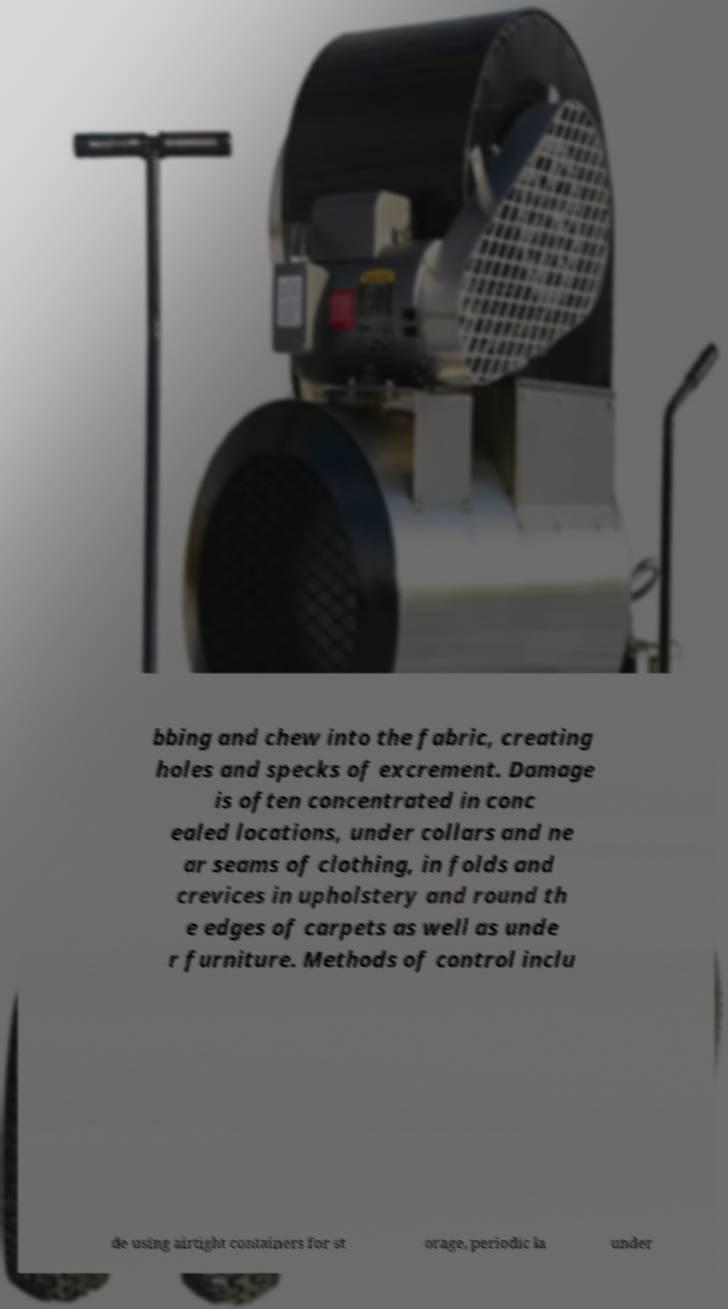Please read and relay the text visible in this image. What does it say? bbing and chew into the fabric, creating holes and specks of excrement. Damage is often concentrated in conc ealed locations, under collars and ne ar seams of clothing, in folds and crevices in upholstery and round th e edges of carpets as well as unde r furniture. Methods of control inclu de using airtight containers for st orage, periodic la under 